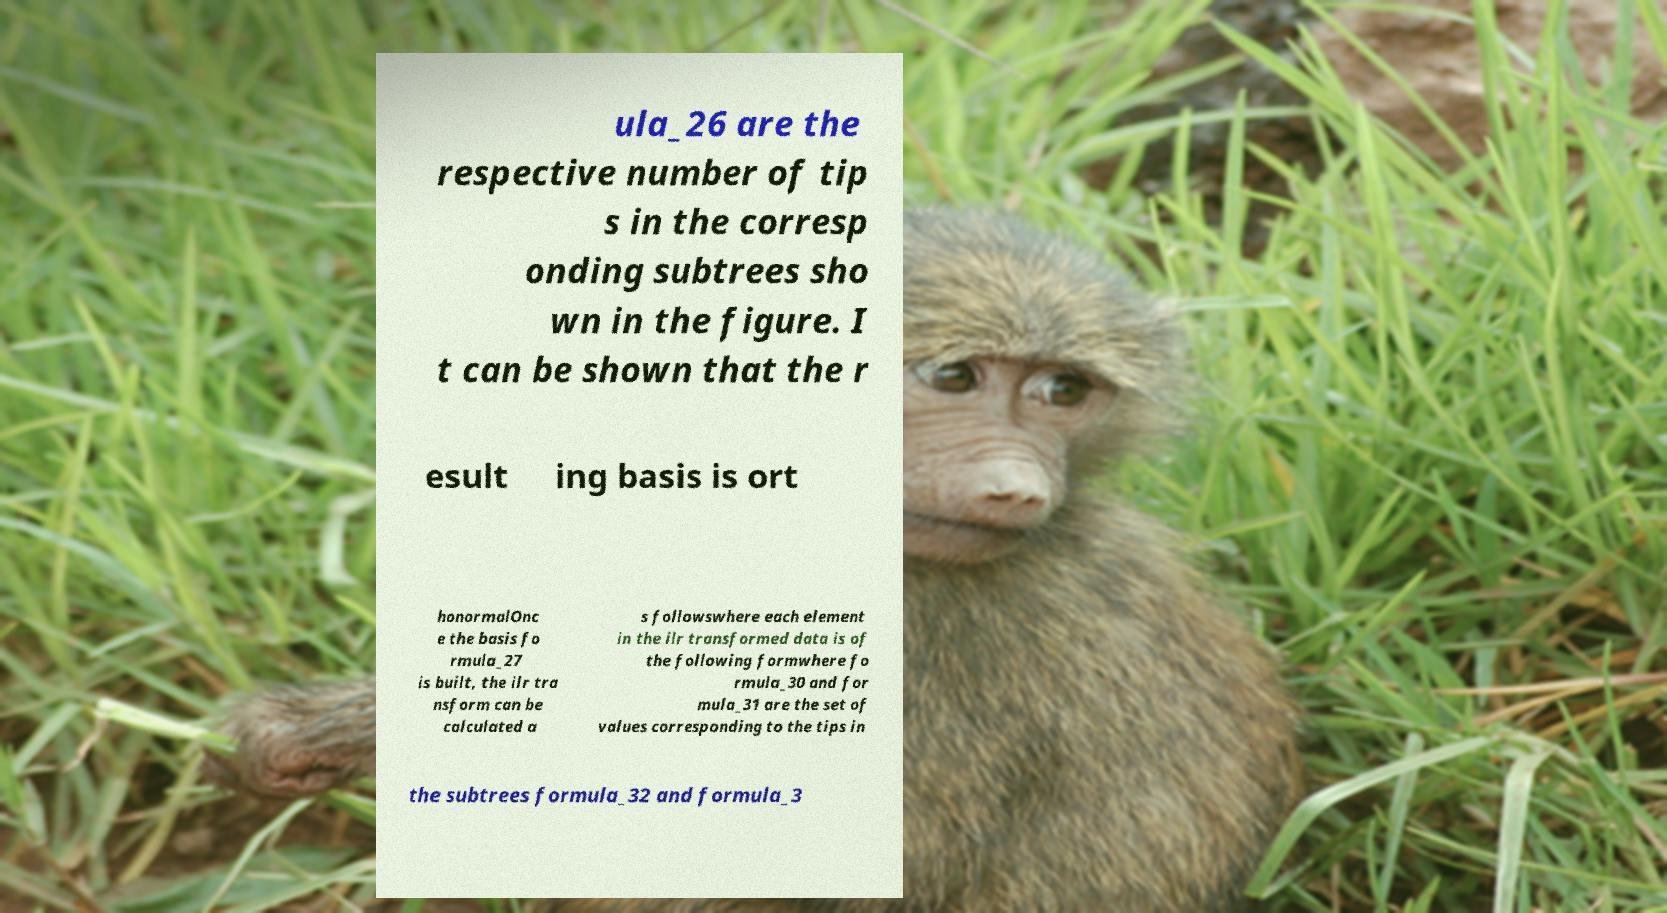Can you read and provide the text displayed in the image?This photo seems to have some interesting text. Can you extract and type it out for me? ula_26 are the respective number of tip s in the corresp onding subtrees sho wn in the figure. I t can be shown that the r esult ing basis is ort honormalOnc e the basis fo rmula_27 is built, the ilr tra nsform can be calculated a s followswhere each element in the ilr transformed data is of the following formwhere fo rmula_30 and for mula_31 are the set of values corresponding to the tips in the subtrees formula_32 and formula_3 